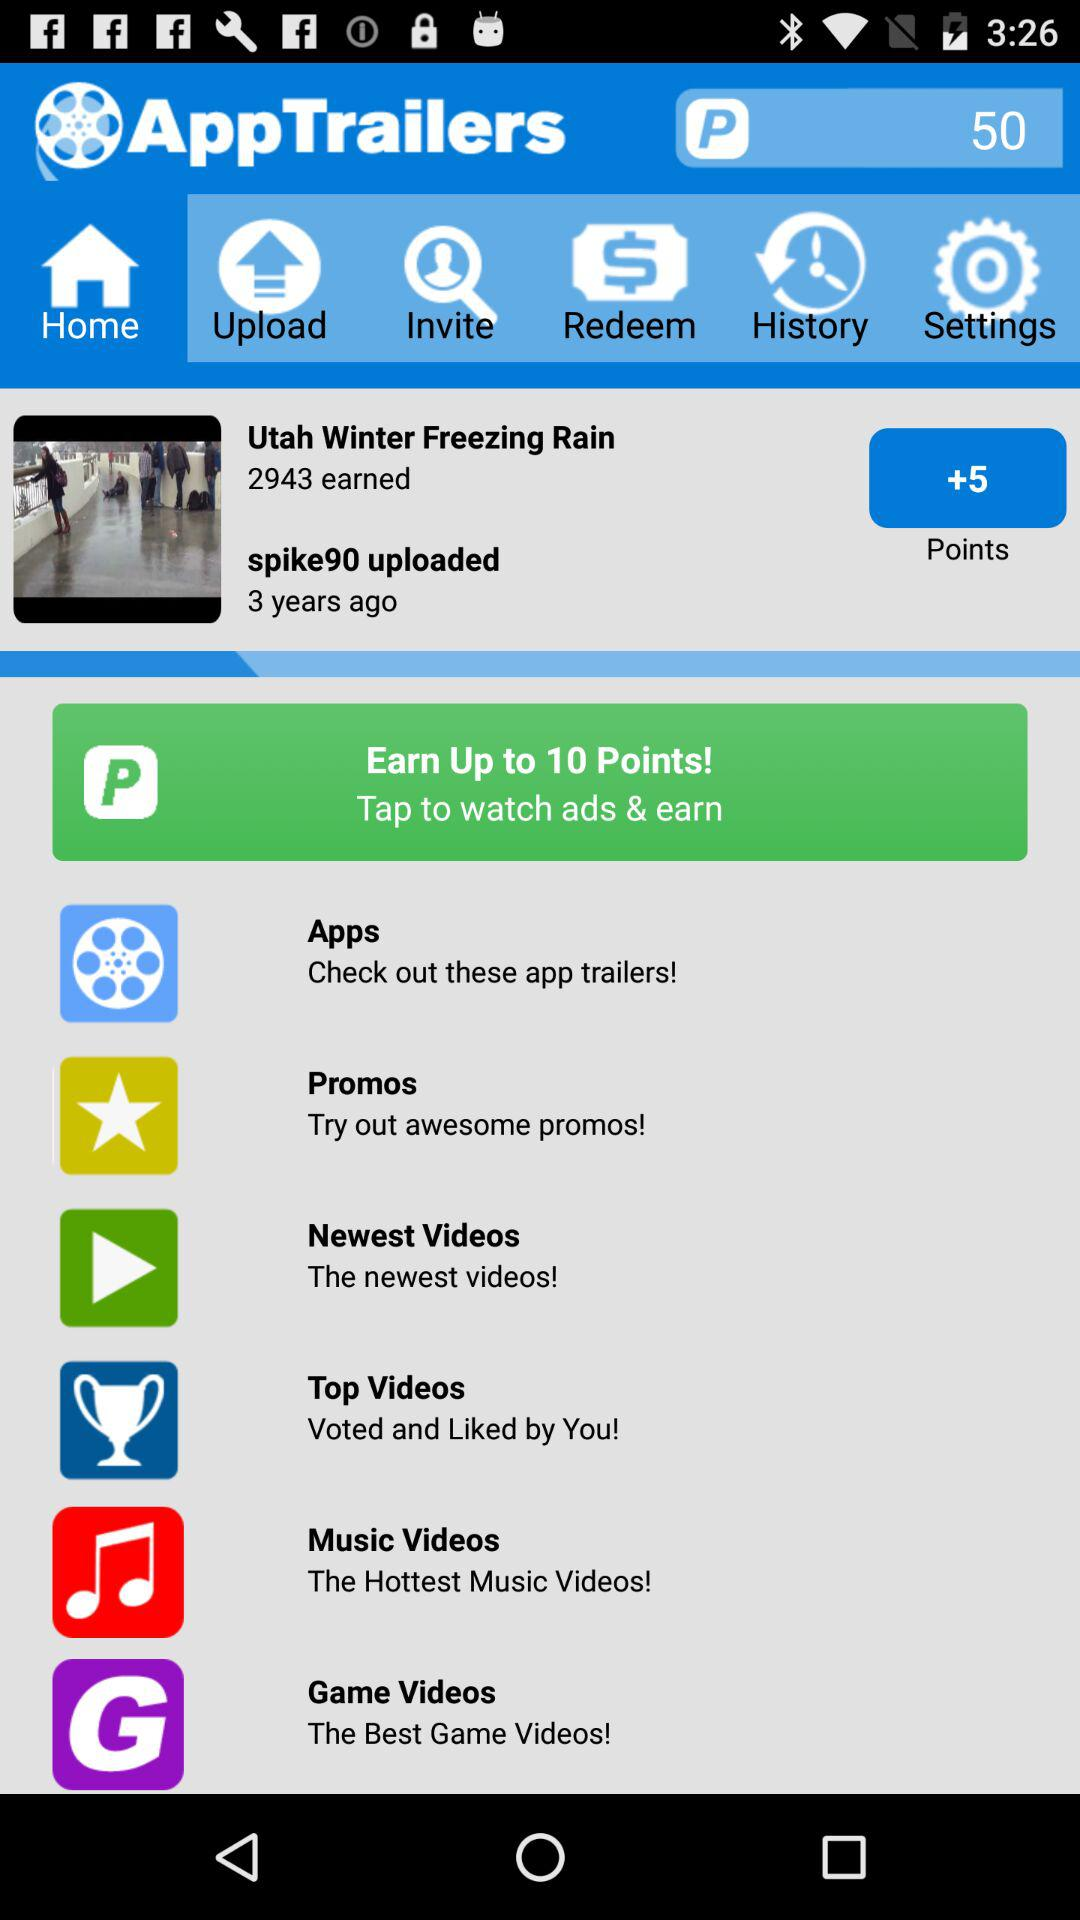How many points are earned? There are 50 points earned. 